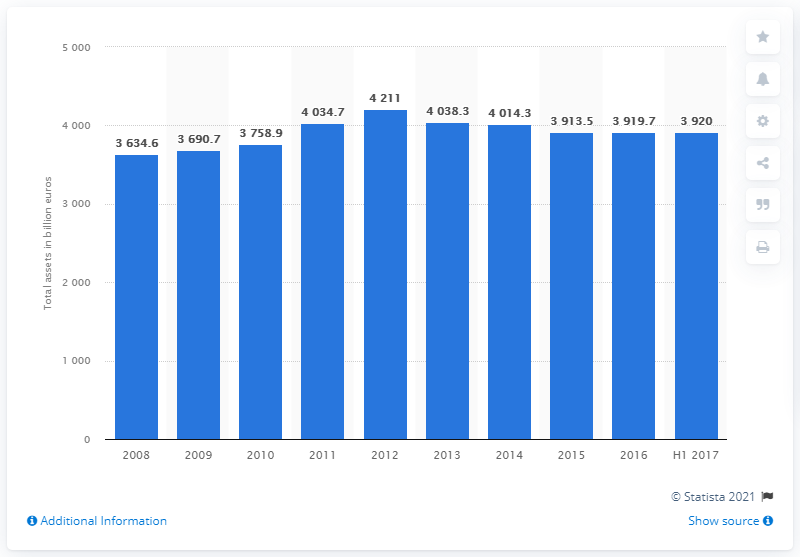Highlight a few significant elements in this photo. As of the first semester of 2017, the total assets of the Italian banking system were approximately 3,920. In 2012, the peak value of the Italian banking sector's assets was 4,211. 